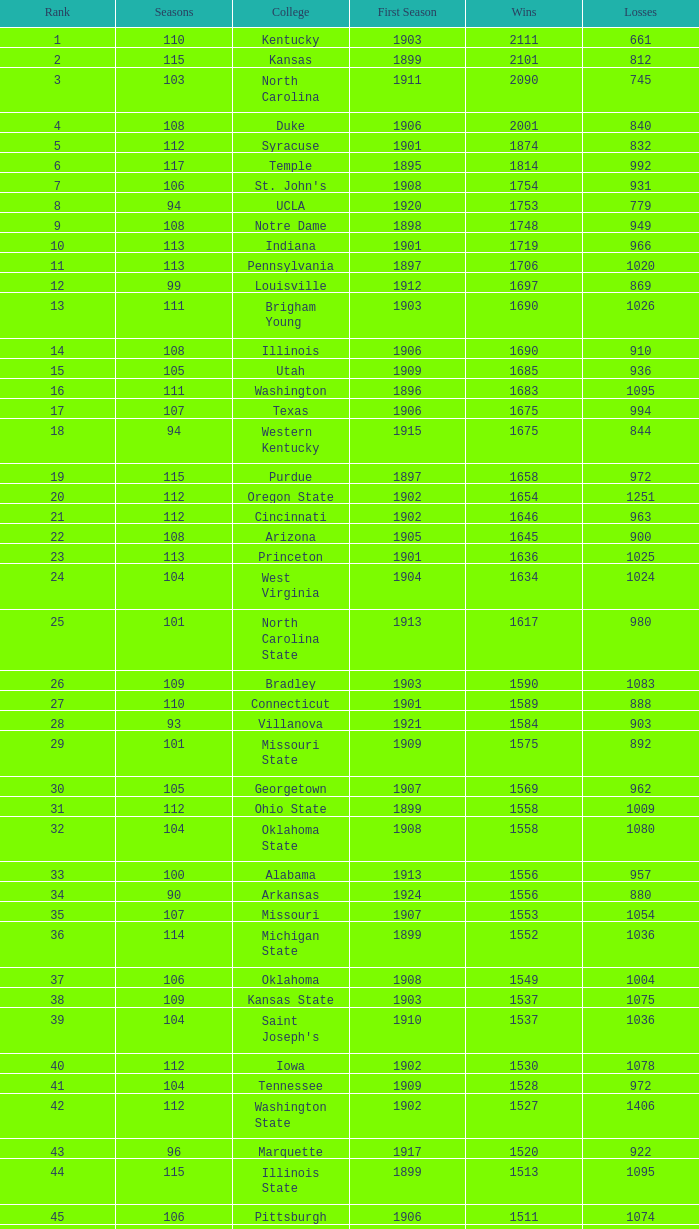What is the total of First Season games with 1537 Wins and a Season greater than 109? None. Give me the full table as a dictionary. {'header': ['Rank', 'Seasons', 'College', 'First Season', 'Wins', 'Losses'], 'rows': [['1', '110', 'Kentucky', '1903', '2111', '661'], ['2', '115', 'Kansas', '1899', '2101', '812'], ['3', '103', 'North Carolina', '1911', '2090', '745'], ['4', '108', 'Duke', '1906', '2001', '840'], ['5', '112', 'Syracuse', '1901', '1874', '832'], ['6', '117', 'Temple', '1895', '1814', '992'], ['7', '106', "St. John's", '1908', '1754', '931'], ['8', '94', 'UCLA', '1920', '1753', '779'], ['9', '108', 'Notre Dame', '1898', '1748', '949'], ['10', '113', 'Indiana', '1901', '1719', '966'], ['11', '113', 'Pennsylvania', '1897', '1706', '1020'], ['12', '99', 'Louisville', '1912', '1697', '869'], ['13', '111', 'Brigham Young', '1903', '1690', '1026'], ['14', '108', 'Illinois', '1906', '1690', '910'], ['15', '105', 'Utah', '1909', '1685', '936'], ['16', '111', 'Washington', '1896', '1683', '1095'], ['17', '107', 'Texas', '1906', '1675', '994'], ['18', '94', 'Western Kentucky', '1915', '1675', '844'], ['19', '115', 'Purdue', '1897', '1658', '972'], ['20', '112', 'Oregon State', '1902', '1654', '1251'], ['21', '112', 'Cincinnati', '1902', '1646', '963'], ['22', '108', 'Arizona', '1905', '1645', '900'], ['23', '113', 'Princeton', '1901', '1636', '1025'], ['24', '104', 'West Virginia', '1904', '1634', '1024'], ['25', '101', 'North Carolina State', '1913', '1617', '980'], ['26', '109', 'Bradley', '1903', '1590', '1083'], ['27', '110', 'Connecticut', '1901', '1589', '888'], ['28', '93', 'Villanova', '1921', '1584', '903'], ['29', '101', 'Missouri State', '1909', '1575', '892'], ['30', '105', 'Georgetown', '1907', '1569', '962'], ['31', '112', 'Ohio State', '1899', '1558', '1009'], ['32', '104', 'Oklahoma State', '1908', '1558', '1080'], ['33', '100', 'Alabama', '1913', '1556', '957'], ['34', '90', 'Arkansas', '1924', '1556', '880'], ['35', '107', 'Missouri', '1907', '1553', '1054'], ['36', '114', 'Michigan State', '1899', '1552', '1036'], ['37', '106', 'Oklahoma', '1908', '1549', '1004'], ['38', '109', 'Kansas State', '1903', '1537', '1075'], ['39', '104', "Saint Joseph's", '1910', '1537', '1036'], ['40', '112', 'Iowa', '1902', '1530', '1078'], ['41', '104', 'Tennessee', '1909', '1528', '972'], ['42', '112', 'Washington State', '1902', '1527', '1406'], ['43', '96', 'Marquette', '1917', '1520', '922'], ['44', '115', 'Illinois State', '1899', '1513', '1095'], ['45', '106', 'Pittsburgh', '1906', '1511', '1074'], ['46', '111', 'Vanderbilt', '1901', '1511', '1063'], ['47', '108', 'Dayton', '1904', '1508', '1053'], ['48', '108', 'Oregon', '1903', '1507', '1303'], ['49', '118', 'Minnesota', '1896', '1502', '1139'], ['50', '88', 'Murray State', '1926', '1501', '835']]} 